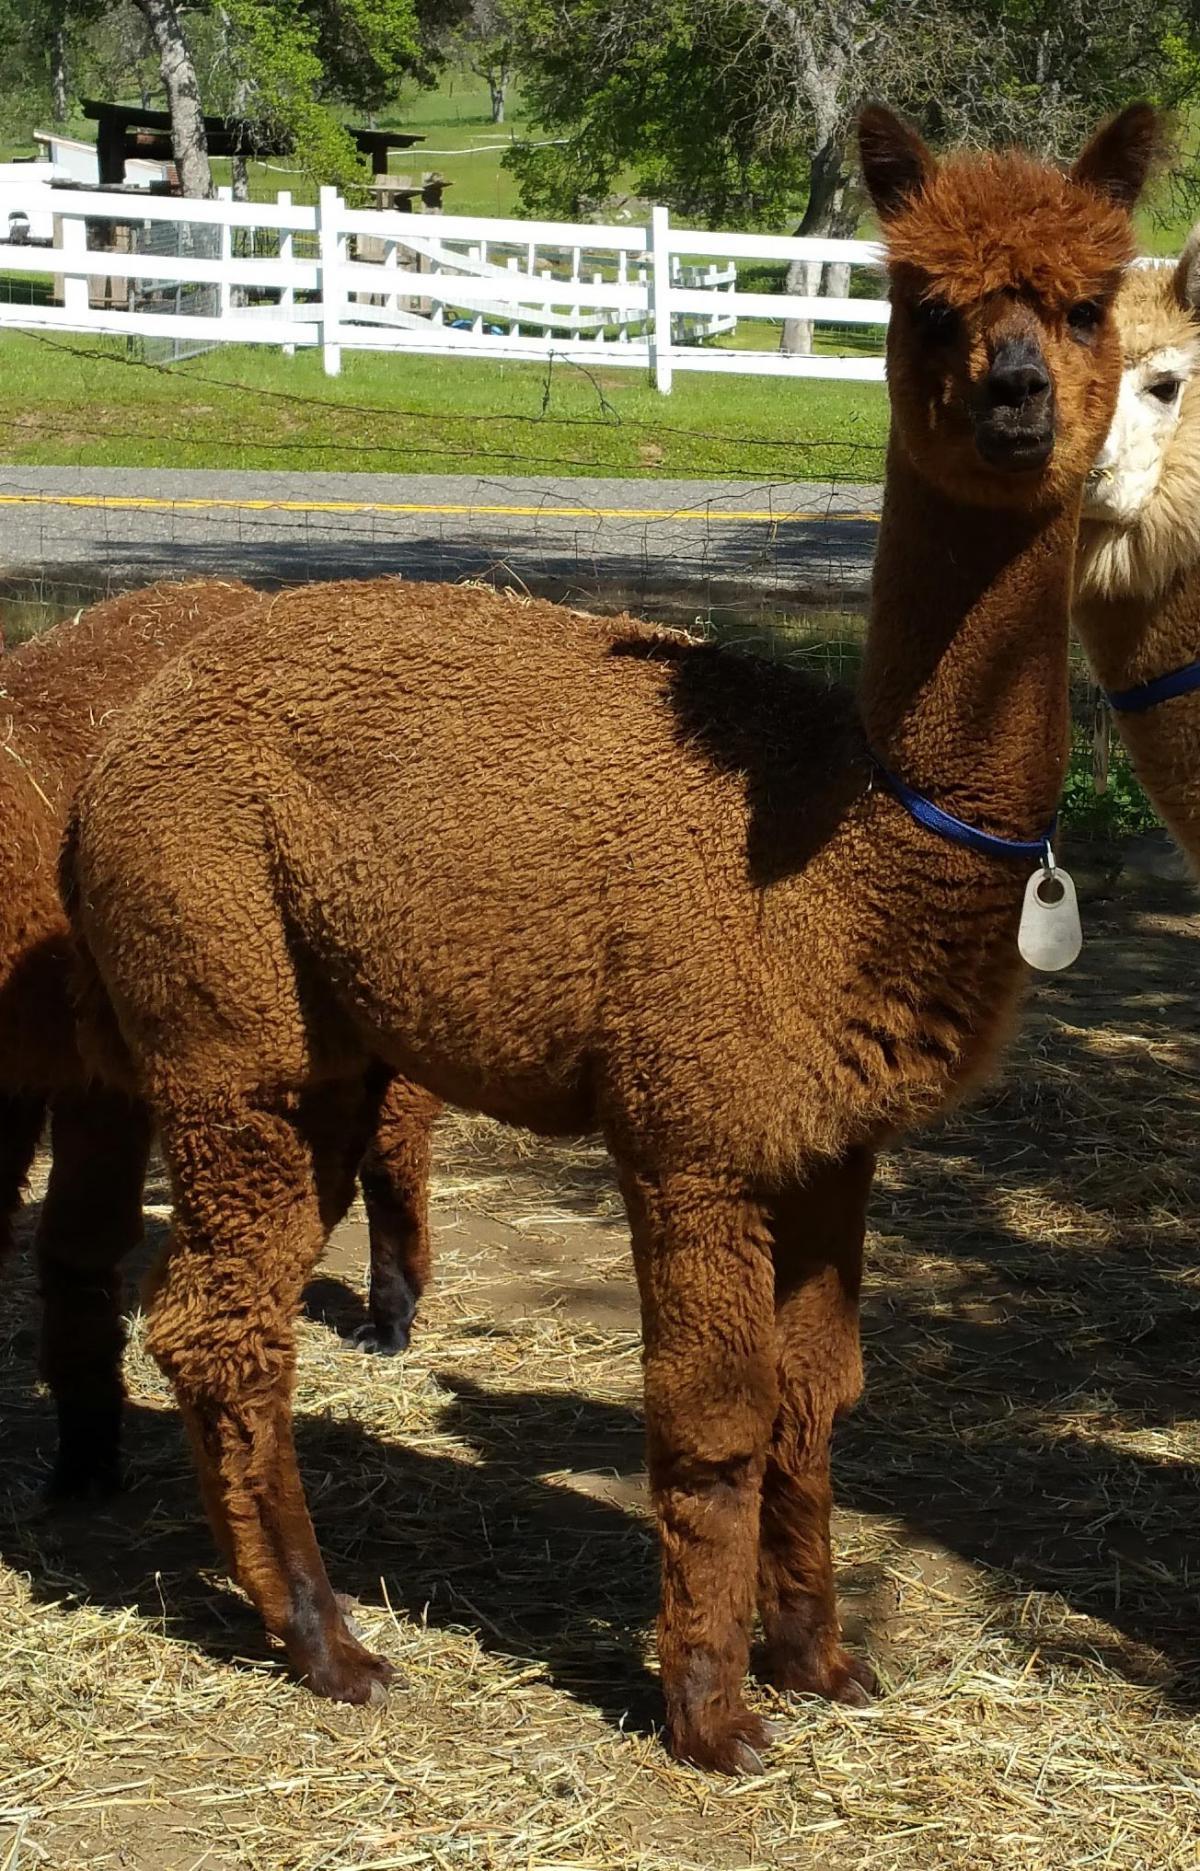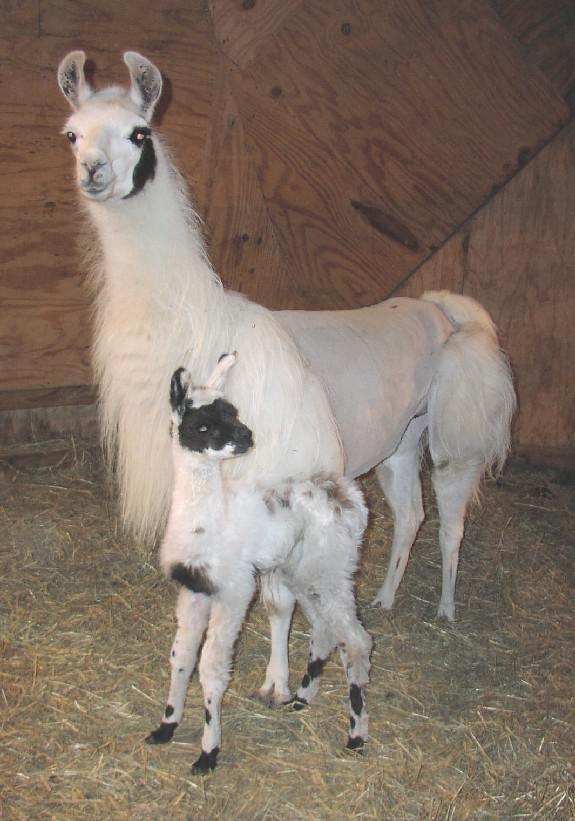The first image is the image on the left, the second image is the image on the right. Examine the images to the left and right. Is the description "In the right image, a baby llama with its body turned left and its head turned right is standing near a standing adult llama." accurate? Answer yes or no. Yes. The first image is the image on the left, the second image is the image on the right. For the images shown, is this caption "One of the images show only two llamas that are facing the same direction as the other." true? Answer yes or no. No. 